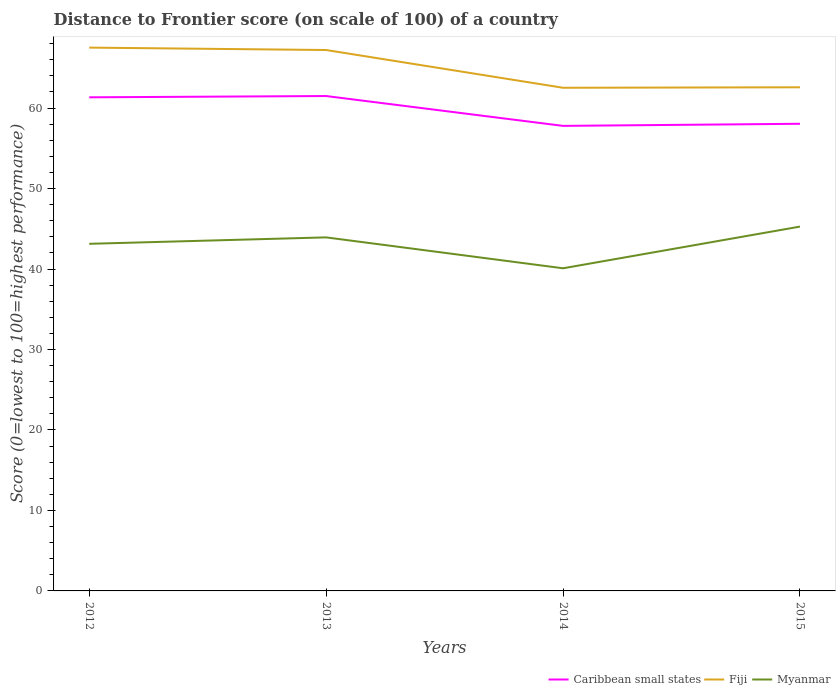How many different coloured lines are there?
Offer a very short reply. 3. Across all years, what is the maximum distance to frontier score of in Myanmar?
Offer a very short reply. 40.09. What is the total distance to frontier score of in Fiji in the graph?
Ensure brevity in your answer.  4.63. What is the difference between the highest and the second highest distance to frontier score of in Fiji?
Your answer should be very brief. 4.99. What is the difference between the highest and the lowest distance to frontier score of in Caribbean small states?
Your response must be concise. 2. Is the distance to frontier score of in Fiji strictly greater than the distance to frontier score of in Myanmar over the years?
Your answer should be very brief. No. How many years are there in the graph?
Your response must be concise. 4. What is the difference between two consecutive major ticks on the Y-axis?
Provide a succinct answer. 10. Are the values on the major ticks of Y-axis written in scientific E-notation?
Your response must be concise. No. Does the graph contain any zero values?
Your response must be concise. No. Does the graph contain grids?
Your answer should be compact. No. How many legend labels are there?
Make the answer very short. 3. What is the title of the graph?
Give a very brief answer. Distance to Frontier score (on scale of 100) of a country. What is the label or title of the Y-axis?
Offer a very short reply. Score (0=lowest to 100=highest performance). What is the Score (0=lowest to 100=highest performance) of Caribbean small states in 2012?
Provide a short and direct response. 61.33. What is the Score (0=lowest to 100=highest performance) in Fiji in 2012?
Keep it short and to the point. 67.51. What is the Score (0=lowest to 100=highest performance) in Myanmar in 2012?
Your response must be concise. 43.13. What is the Score (0=lowest to 100=highest performance) in Caribbean small states in 2013?
Offer a very short reply. 61.49. What is the Score (0=lowest to 100=highest performance) of Fiji in 2013?
Provide a short and direct response. 67.21. What is the Score (0=lowest to 100=highest performance) in Myanmar in 2013?
Your answer should be compact. 43.93. What is the Score (0=lowest to 100=highest performance) of Caribbean small states in 2014?
Provide a succinct answer. 57.78. What is the Score (0=lowest to 100=highest performance) in Fiji in 2014?
Provide a succinct answer. 62.52. What is the Score (0=lowest to 100=highest performance) in Myanmar in 2014?
Give a very brief answer. 40.09. What is the Score (0=lowest to 100=highest performance) of Caribbean small states in 2015?
Provide a short and direct response. 58.05. What is the Score (0=lowest to 100=highest performance) in Fiji in 2015?
Your response must be concise. 62.58. What is the Score (0=lowest to 100=highest performance) of Myanmar in 2015?
Make the answer very short. 45.27. Across all years, what is the maximum Score (0=lowest to 100=highest performance) in Caribbean small states?
Provide a short and direct response. 61.49. Across all years, what is the maximum Score (0=lowest to 100=highest performance) in Fiji?
Offer a terse response. 67.51. Across all years, what is the maximum Score (0=lowest to 100=highest performance) in Myanmar?
Offer a very short reply. 45.27. Across all years, what is the minimum Score (0=lowest to 100=highest performance) of Caribbean small states?
Provide a short and direct response. 57.78. Across all years, what is the minimum Score (0=lowest to 100=highest performance) in Fiji?
Your answer should be compact. 62.52. Across all years, what is the minimum Score (0=lowest to 100=highest performance) in Myanmar?
Keep it short and to the point. 40.09. What is the total Score (0=lowest to 100=highest performance) of Caribbean small states in the graph?
Provide a short and direct response. 238.66. What is the total Score (0=lowest to 100=highest performance) of Fiji in the graph?
Your answer should be compact. 259.82. What is the total Score (0=lowest to 100=highest performance) of Myanmar in the graph?
Give a very brief answer. 172.42. What is the difference between the Score (0=lowest to 100=highest performance) in Caribbean small states in 2012 and that in 2013?
Offer a very short reply. -0.16. What is the difference between the Score (0=lowest to 100=highest performance) in Caribbean small states in 2012 and that in 2014?
Your response must be concise. 3.55. What is the difference between the Score (0=lowest to 100=highest performance) in Fiji in 2012 and that in 2014?
Your answer should be compact. 4.99. What is the difference between the Score (0=lowest to 100=highest performance) in Myanmar in 2012 and that in 2014?
Your answer should be very brief. 3.04. What is the difference between the Score (0=lowest to 100=highest performance) of Caribbean small states in 2012 and that in 2015?
Your answer should be very brief. 3.29. What is the difference between the Score (0=lowest to 100=highest performance) in Fiji in 2012 and that in 2015?
Keep it short and to the point. 4.93. What is the difference between the Score (0=lowest to 100=highest performance) in Myanmar in 2012 and that in 2015?
Give a very brief answer. -2.14. What is the difference between the Score (0=lowest to 100=highest performance) in Caribbean small states in 2013 and that in 2014?
Offer a very short reply. 3.71. What is the difference between the Score (0=lowest to 100=highest performance) in Fiji in 2013 and that in 2014?
Offer a very short reply. 4.69. What is the difference between the Score (0=lowest to 100=highest performance) in Myanmar in 2013 and that in 2014?
Your response must be concise. 3.84. What is the difference between the Score (0=lowest to 100=highest performance) of Caribbean small states in 2013 and that in 2015?
Your answer should be very brief. 3.45. What is the difference between the Score (0=lowest to 100=highest performance) in Fiji in 2013 and that in 2015?
Keep it short and to the point. 4.63. What is the difference between the Score (0=lowest to 100=highest performance) in Myanmar in 2013 and that in 2015?
Give a very brief answer. -1.34. What is the difference between the Score (0=lowest to 100=highest performance) of Caribbean small states in 2014 and that in 2015?
Offer a very short reply. -0.26. What is the difference between the Score (0=lowest to 100=highest performance) in Fiji in 2014 and that in 2015?
Provide a short and direct response. -0.06. What is the difference between the Score (0=lowest to 100=highest performance) in Myanmar in 2014 and that in 2015?
Make the answer very short. -5.18. What is the difference between the Score (0=lowest to 100=highest performance) of Caribbean small states in 2012 and the Score (0=lowest to 100=highest performance) of Fiji in 2013?
Offer a very short reply. -5.88. What is the difference between the Score (0=lowest to 100=highest performance) in Caribbean small states in 2012 and the Score (0=lowest to 100=highest performance) in Myanmar in 2013?
Ensure brevity in your answer.  17.4. What is the difference between the Score (0=lowest to 100=highest performance) in Fiji in 2012 and the Score (0=lowest to 100=highest performance) in Myanmar in 2013?
Your answer should be compact. 23.58. What is the difference between the Score (0=lowest to 100=highest performance) in Caribbean small states in 2012 and the Score (0=lowest to 100=highest performance) in Fiji in 2014?
Offer a terse response. -1.19. What is the difference between the Score (0=lowest to 100=highest performance) of Caribbean small states in 2012 and the Score (0=lowest to 100=highest performance) of Myanmar in 2014?
Provide a succinct answer. 21.24. What is the difference between the Score (0=lowest to 100=highest performance) of Fiji in 2012 and the Score (0=lowest to 100=highest performance) of Myanmar in 2014?
Offer a terse response. 27.42. What is the difference between the Score (0=lowest to 100=highest performance) in Caribbean small states in 2012 and the Score (0=lowest to 100=highest performance) in Fiji in 2015?
Your answer should be compact. -1.25. What is the difference between the Score (0=lowest to 100=highest performance) of Caribbean small states in 2012 and the Score (0=lowest to 100=highest performance) of Myanmar in 2015?
Your answer should be very brief. 16.06. What is the difference between the Score (0=lowest to 100=highest performance) of Fiji in 2012 and the Score (0=lowest to 100=highest performance) of Myanmar in 2015?
Ensure brevity in your answer.  22.24. What is the difference between the Score (0=lowest to 100=highest performance) of Caribbean small states in 2013 and the Score (0=lowest to 100=highest performance) of Fiji in 2014?
Provide a succinct answer. -1.03. What is the difference between the Score (0=lowest to 100=highest performance) of Caribbean small states in 2013 and the Score (0=lowest to 100=highest performance) of Myanmar in 2014?
Offer a very short reply. 21.4. What is the difference between the Score (0=lowest to 100=highest performance) of Fiji in 2013 and the Score (0=lowest to 100=highest performance) of Myanmar in 2014?
Provide a succinct answer. 27.12. What is the difference between the Score (0=lowest to 100=highest performance) of Caribbean small states in 2013 and the Score (0=lowest to 100=highest performance) of Fiji in 2015?
Provide a succinct answer. -1.09. What is the difference between the Score (0=lowest to 100=highest performance) in Caribbean small states in 2013 and the Score (0=lowest to 100=highest performance) in Myanmar in 2015?
Offer a very short reply. 16.22. What is the difference between the Score (0=lowest to 100=highest performance) of Fiji in 2013 and the Score (0=lowest to 100=highest performance) of Myanmar in 2015?
Keep it short and to the point. 21.94. What is the difference between the Score (0=lowest to 100=highest performance) of Caribbean small states in 2014 and the Score (0=lowest to 100=highest performance) of Fiji in 2015?
Keep it short and to the point. -4.8. What is the difference between the Score (0=lowest to 100=highest performance) of Caribbean small states in 2014 and the Score (0=lowest to 100=highest performance) of Myanmar in 2015?
Your answer should be compact. 12.51. What is the difference between the Score (0=lowest to 100=highest performance) in Fiji in 2014 and the Score (0=lowest to 100=highest performance) in Myanmar in 2015?
Offer a very short reply. 17.25. What is the average Score (0=lowest to 100=highest performance) of Caribbean small states per year?
Your answer should be very brief. 59.66. What is the average Score (0=lowest to 100=highest performance) in Fiji per year?
Offer a terse response. 64.95. What is the average Score (0=lowest to 100=highest performance) of Myanmar per year?
Your answer should be compact. 43.1. In the year 2012, what is the difference between the Score (0=lowest to 100=highest performance) of Caribbean small states and Score (0=lowest to 100=highest performance) of Fiji?
Keep it short and to the point. -6.18. In the year 2012, what is the difference between the Score (0=lowest to 100=highest performance) in Caribbean small states and Score (0=lowest to 100=highest performance) in Myanmar?
Your answer should be very brief. 18.2. In the year 2012, what is the difference between the Score (0=lowest to 100=highest performance) in Fiji and Score (0=lowest to 100=highest performance) in Myanmar?
Give a very brief answer. 24.38. In the year 2013, what is the difference between the Score (0=lowest to 100=highest performance) of Caribbean small states and Score (0=lowest to 100=highest performance) of Fiji?
Offer a very short reply. -5.72. In the year 2013, what is the difference between the Score (0=lowest to 100=highest performance) of Caribbean small states and Score (0=lowest to 100=highest performance) of Myanmar?
Make the answer very short. 17.56. In the year 2013, what is the difference between the Score (0=lowest to 100=highest performance) in Fiji and Score (0=lowest to 100=highest performance) in Myanmar?
Your answer should be very brief. 23.28. In the year 2014, what is the difference between the Score (0=lowest to 100=highest performance) of Caribbean small states and Score (0=lowest to 100=highest performance) of Fiji?
Provide a succinct answer. -4.74. In the year 2014, what is the difference between the Score (0=lowest to 100=highest performance) in Caribbean small states and Score (0=lowest to 100=highest performance) in Myanmar?
Give a very brief answer. 17.69. In the year 2014, what is the difference between the Score (0=lowest to 100=highest performance) of Fiji and Score (0=lowest to 100=highest performance) of Myanmar?
Ensure brevity in your answer.  22.43. In the year 2015, what is the difference between the Score (0=lowest to 100=highest performance) in Caribbean small states and Score (0=lowest to 100=highest performance) in Fiji?
Your response must be concise. -4.53. In the year 2015, what is the difference between the Score (0=lowest to 100=highest performance) in Caribbean small states and Score (0=lowest to 100=highest performance) in Myanmar?
Ensure brevity in your answer.  12.78. In the year 2015, what is the difference between the Score (0=lowest to 100=highest performance) in Fiji and Score (0=lowest to 100=highest performance) in Myanmar?
Offer a terse response. 17.31. What is the ratio of the Score (0=lowest to 100=highest performance) in Caribbean small states in 2012 to that in 2013?
Offer a terse response. 1. What is the ratio of the Score (0=lowest to 100=highest performance) in Fiji in 2012 to that in 2013?
Give a very brief answer. 1. What is the ratio of the Score (0=lowest to 100=highest performance) in Myanmar in 2012 to that in 2013?
Your answer should be very brief. 0.98. What is the ratio of the Score (0=lowest to 100=highest performance) in Caribbean small states in 2012 to that in 2014?
Provide a succinct answer. 1.06. What is the ratio of the Score (0=lowest to 100=highest performance) in Fiji in 2012 to that in 2014?
Provide a succinct answer. 1.08. What is the ratio of the Score (0=lowest to 100=highest performance) of Myanmar in 2012 to that in 2014?
Your answer should be very brief. 1.08. What is the ratio of the Score (0=lowest to 100=highest performance) in Caribbean small states in 2012 to that in 2015?
Provide a succinct answer. 1.06. What is the ratio of the Score (0=lowest to 100=highest performance) of Fiji in 2012 to that in 2015?
Keep it short and to the point. 1.08. What is the ratio of the Score (0=lowest to 100=highest performance) in Myanmar in 2012 to that in 2015?
Your answer should be very brief. 0.95. What is the ratio of the Score (0=lowest to 100=highest performance) of Caribbean small states in 2013 to that in 2014?
Offer a terse response. 1.06. What is the ratio of the Score (0=lowest to 100=highest performance) in Fiji in 2013 to that in 2014?
Your response must be concise. 1.07. What is the ratio of the Score (0=lowest to 100=highest performance) of Myanmar in 2013 to that in 2014?
Your answer should be very brief. 1.1. What is the ratio of the Score (0=lowest to 100=highest performance) in Caribbean small states in 2013 to that in 2015?
Offer a terse response. 1.06. What is the ratio of the Score (0=lowest to 100=highest performance) in Fiji in 2013 to that in 2015?
Ensure brevity in your answer.  1.07. What is the ratio of the Score (0=lowest to 100=highest performance) in Myanmar in 2013 to that in 2015?
Offer a very short reply. 0.97. What is the ratio of the Score (0=lowest to 100=highest performance) of Caribbean small states in 2014 to that in 2015?
Keep it short and to the point. 1. What is the ratio of the Score (0=lowest to 100=highest performance) of Myanmar in 2014 to that in 2015?
Offer a very short reply. 0.89. What is the difference between the highest and the second highest Score (0=lowest to 100=highest performance) of Caribbean small states?
Give a very brief answer. 0.16. What is the difference between the highest and the second highest Score (0=lowest to 100=highest performance) of Fiji?
Offer a terse response. 0.3. What is the difference between the highest and the second highest Score (0=lowest to 100=highest performance) in Myanmar?
Your response must be concise. 1.34. What is the difference between the highest and the lowest Score (0=lowest to 100=highest performance) of Caribbean small states?
Provide a succinct answer. 3.71. What is the difference between the highest and the lowest Score (0=lowest to 100=highest performance) in Fiji?
Ensure brevity in your answer.  4.99. What is the difference between the highest and the lowest Score (0=lowest to 100=highest performance) in Myanmar?
Provide a succinct answer. 5.18. 